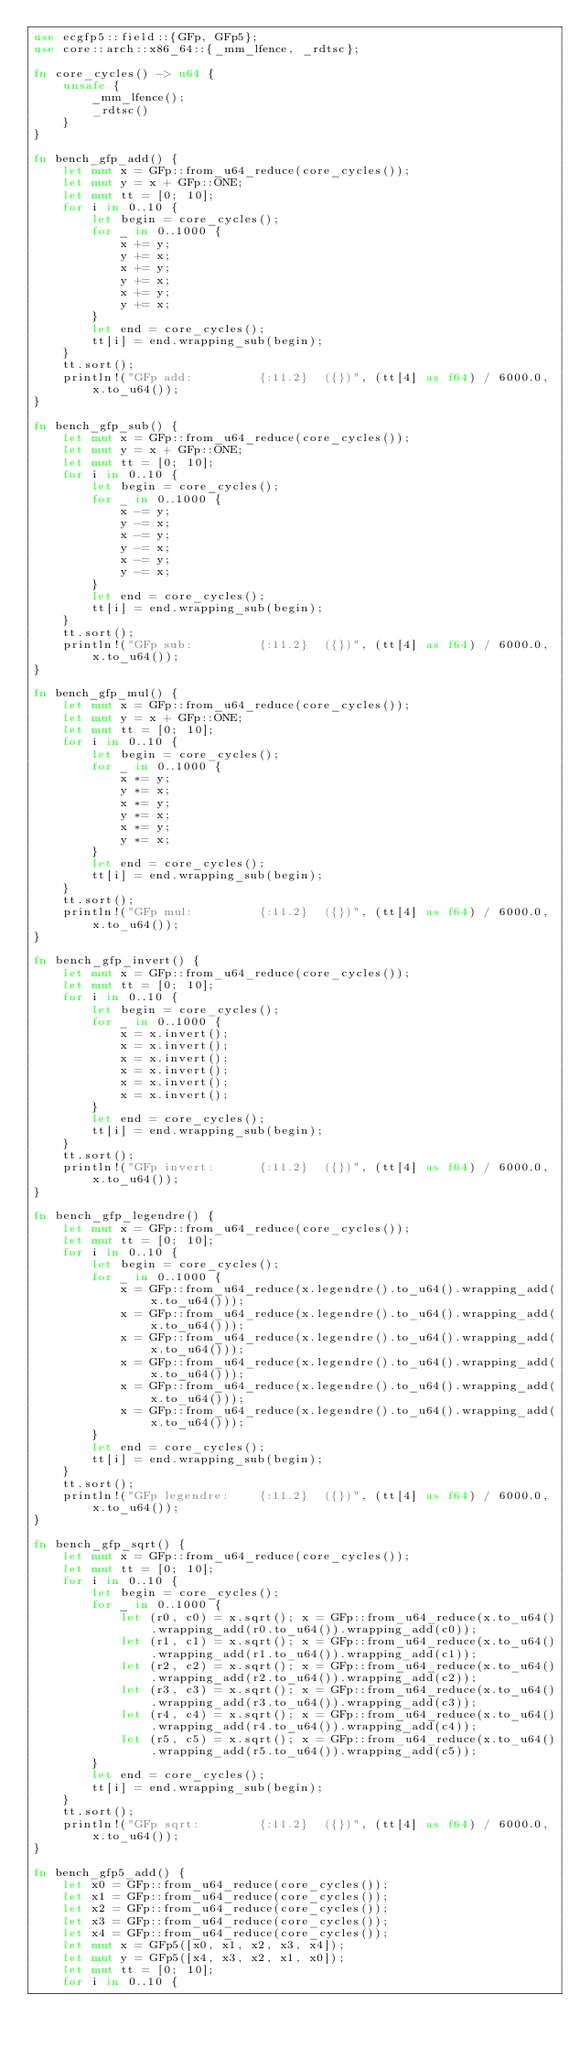<code> <loc_0><loc_0><loc_500><loc_500><_Rust_>use ecgfp5::field::{GFp, GFp5};
use core::arch::x86_64::{_mm_lfence, _rdtsc};

fn core_cycles() -> u64 {
    unsafe {
        _mm_lfence();
        _rdtsc()
    }
}

fn bench_gfp_add() {
    let mut x = GFp::from_u64_reduce(core_cycles());
    let mut y = x + GFp::ONE;
    let mut tt = [0; 10];
    for i in 0..10 {
        let begin = core_cycles();
        for _ in 0..1000 {
            x += y;
            y += x;
            x += y;
            y += x;
            x += y;
            y += x;
        }
        let end = core_cycles();
        tt[i] = end.wrapping_sub(begin);
    }
    tt.sort();
    println!("GFp add:         {:11.2}  ({})", (tt[4] as f64) / 6000.0, x.to_u64());
}

fn bench_gfp_sub() {
    let mut x = GFp::from_u64_reduce(core_cycles());
    let mut y = x + GFp::ONE;
    let mut tt = [0; 10];
    for i in 0..10 {
        let begin = core_cycles();
        for _ in 0..1000 {
            x -= y;
            y -= x;
            x -= y;
            y -= x;
            x -= y;
            y -= x;
        }
        let end = core_cycles();
        tt[i] = end.wrapping_sub(begin);
    }
    tt.sort();
    println!("GFp sub:         {:11.2}  ({})", (tt[4] as f64) / 6000.0, x.to_u64());
}

fn bench_gfp_mul() {
    let mut x = GFp::from_u64_reduce(core_cycles());
    let mut y = x + GFp::ONE;
    let mut tt = [0; 10];
    for i in 0..10 {
        let begin = core_cycles();
        for _ in 0..1000 {
            x *= y;
            y *= x;
            x *= y;
            y *= x;
            x *= y;
            y *= x;
        }
        let end = core_cycles();
        tt[i] = end.wrapping_sub(begin);
    }
    tt.sort();
    println!("GFp mul:         {:11.2}  ({})", (tt[4] as f64) / 6000.0, x.to_u64());
}

fn bench_gfp_invert() {
    let mut x = GFp::from_u64_reduce(core_cycles());
    let mut tt = [0; 10];
    for i in 0..10 {
        let begin = core_cycles();
        for _ in 0..1000 {
            x = x.invert();
            x = x.invert();
            x = x.invert();
            x = x.invert();
            x = x.invert();
            x = x.invert();
        }
        let end = core_cycles();
        tt[i] = end.wrapping_sub(begin);
    }
    tt.sort();
    println!("GFp invert:      {:11.2}  ({})", (tt[4] as f64) / 6000.0, x.to_u64());
}

fn bench_gfp_legendre() {
    let mut x = GFp::from_u64_reduce(core_cycles());
    let mut tt = [0; 10];
    for i in 0..10 {
        let begin = core_cycles();
        for _ in 0..1000 {
            x = GFp::from_u64_reduce(x.legendre().to_u64().wrapping_add(x.to_u64()));
            x = GFp::from_u64_reduce(x.legendre().to_u64().wrapping_add(x.to_u64()));
            x = GFp::from_u64_reduce(x.legendre().to_u64().wrapping_add(x.to_u64()));
            x = GFp::from_u64_reduce(x.legendre().to_u64().wrapping_add(x.to_u64()));
            x = GFp::from_u64_reduce(x.legendre().to_u64().wrapping_add(x.to_u64()));
            x = GFp::from_u64_reduce(x.legendre().to_u64().wrapping_add(x.to_u64()));
        }
        let end = core_cycles();
        tt[i] = end.wrapping_sub(begin);
    }
    tt.sort();
    println!("GFp legendre:    {:11.2}  ({})", (tt[4] as f64) / 6000.0, x.to_u64());
}

fn bench_gfp_sqrt() {
    let mut x = GFp::from_u64_reduce(core_cycles());
    let mut tt = [0; 10];
    for i in 0..10 {
        let begin = core_cycles();
        for _ in 0..1000 {
            let (r0, c0) = x.sqrt(); x = GFp::from_u64_reduce(x.to_u64().wrapping_add(r0.to_u64()).wrapping_add(c0));
            let (r1, c1) = x.sqrt(); x = GFp::from_u64_reduce(x.to_u64().wrapping_add(r1.to_u64()).wrapping_add(c1));
            let (r2, c2) = x.sqrt(); x = GFp::from_u64_reduce(x.to_u64().wrapping_add(r2.to_u64()).wrapping_add(c2));
            let (r3, c3) = x.sqrt(); x = GFp::from_u64_reduce(x.to_u64().wrapping_add(r3.to_u64()).wrapping_add(c3));
            let (r4, c4) = x.sqrt(); x = GFp::from_u64_reduce(x.to_u64().wrapping_add(r4.to_u64()).wrapping_add(c4));
            let (r5, c5) = x.sqrt(); x = GFp::from_u64_reduce(x.to_u64().wrapping_add(r5.to_u64()).wrapping_add(c5));
        }
        let end = core_cycles();
        tt[i] = end.wrapping_sub(begin);
    }
    tt.sort();
    println!("GFp sqrt:        {:11.2}  ({})", (tt[4] as f64) / 6000.0, x.to_u64());
}

fn bench_gfp5_add() {
    let x0 = GFp::from_u64_reduce(core_cycles());
    let x1 = GFp::from_u64_reduce(core_cycles());
    let x2 = GFp::from_u64_reduce(core_cycles());
    let x3 = GFp::from_u64_reduce(core_cycles());
    let x4 = GFp::from_u64_reduce(core_cycles());
    let mut x = GFp5([x0, x1, x2, x3, x4]);
    let mut y = GFp5([x4, x3, x2, x1, x0]);
    let mut tt = [0; 10];
    for i in 0..10 {</code> 